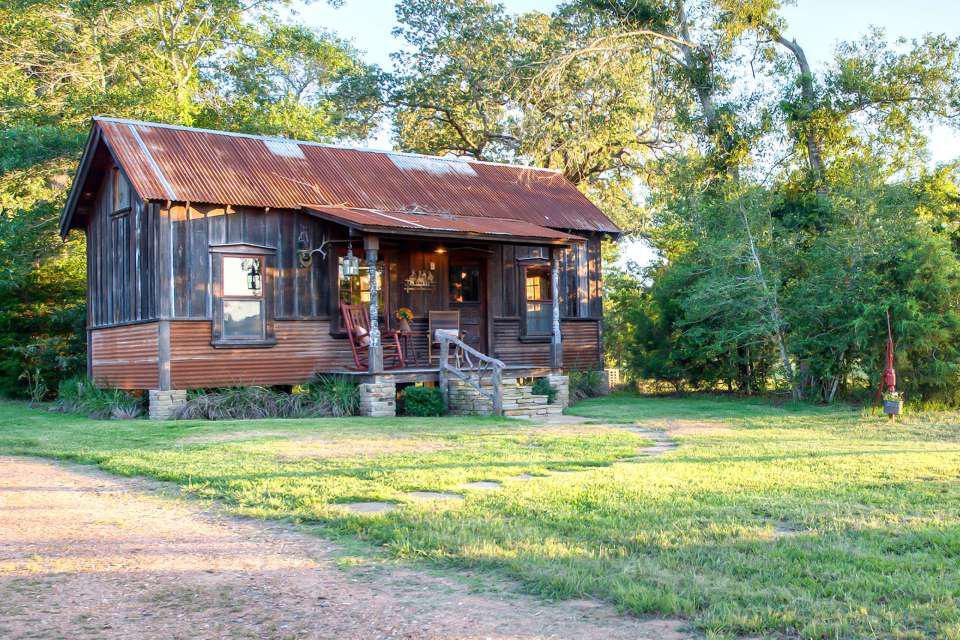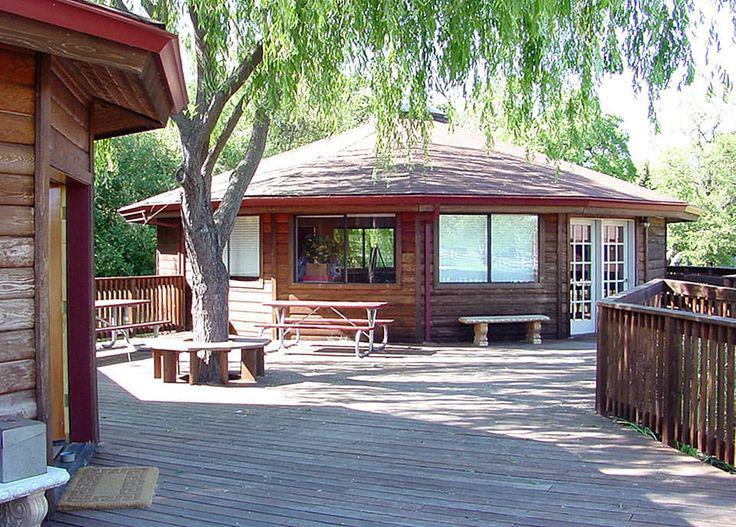The first image is the image on the left, the second image is the image on the right. For the images shown, is this caption "In one image, a round house has a round wrap-around porch." true? Answer yes or no. No. The first image is the image on the left, the second image is the image on the right. Given the left and right images, does the statement "An image shows a round house on stilts surrounded by a railing and deck." hold true? Answer yes or no. No. 